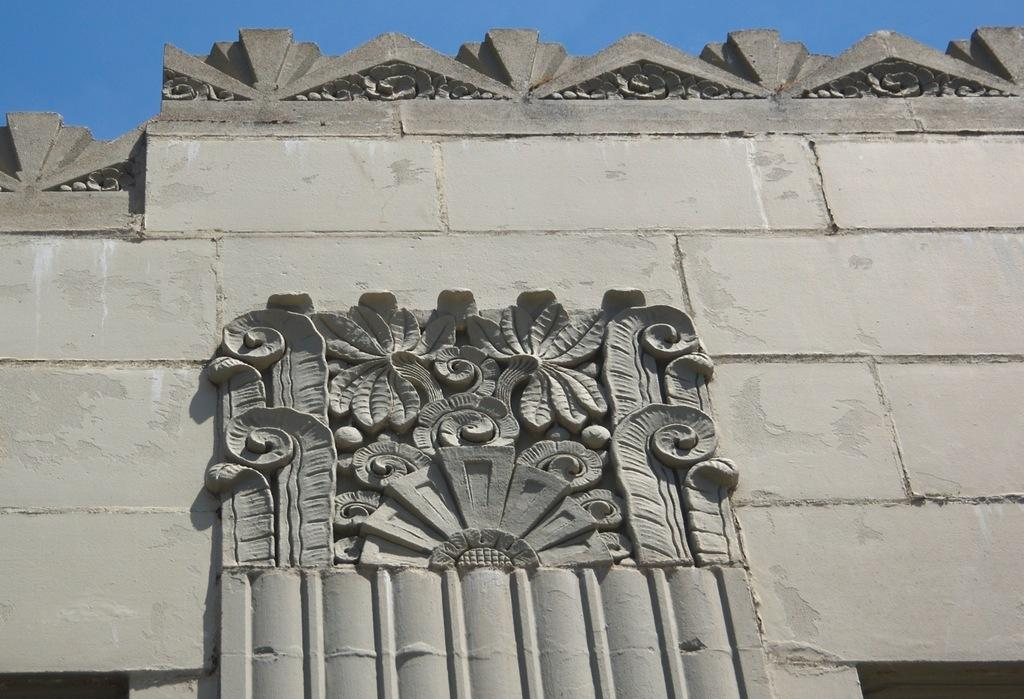What type of structure is visible in the image? There is a building in the image. What can be seen on the wall of the building? There is carving on the wall of the building. What color is the sky in the image? The sky is blue in the image. How many babies are present in the image? There are no babies present in the image. What type of help can be seen being provided in the image? There is no help being provided in the image; it only features a building with carving on the wall and a blue sky. 